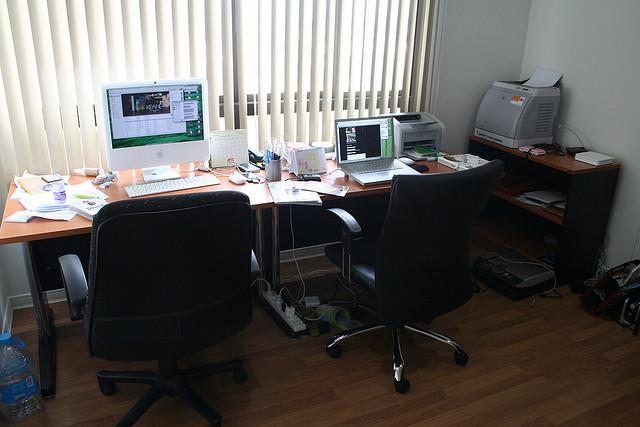What kind of flooring is this?
Short answer required. Wood. How many printers are there?
Quick response, please. 2. Is this indoors?
Write a very short answer. Yes. 